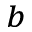<formula> <loc_0><loc_0><loc_500><loc_500>^ { b }</formula> 